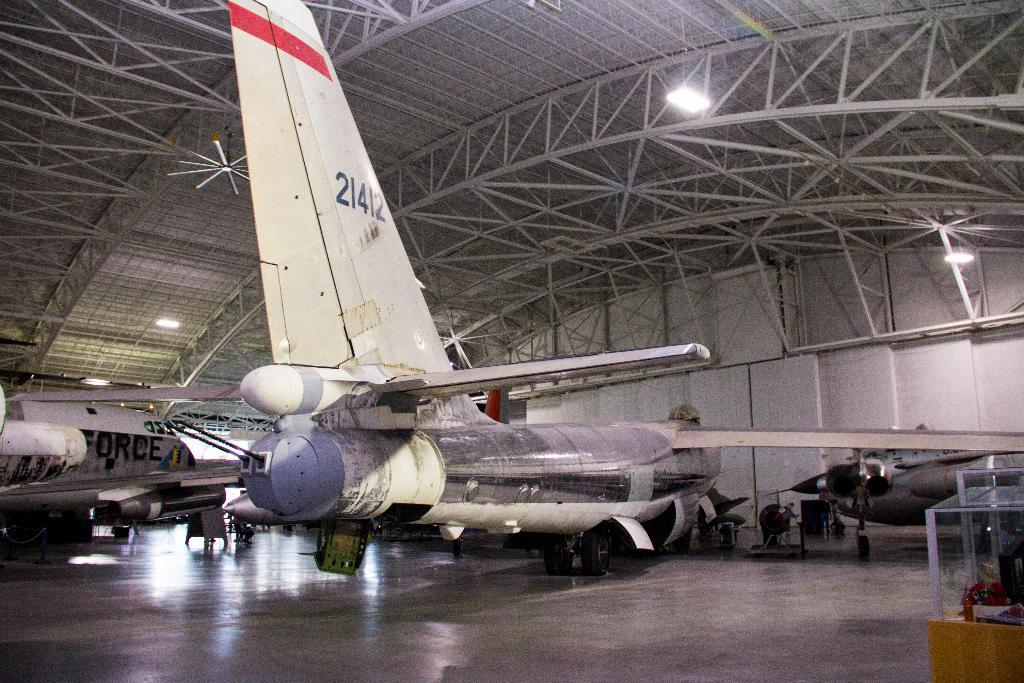What type of vehicles are inside the shed in the image? There are airplanes in a shed in the image. What can be seen in the image besides the airplanes? There are lights and iron rods visible in the image. What are the objects in glass boxes in the image? The objects in glass boxes are not specified in the provided facts. What type of pear is being used as a decoration in the cemetery in the image? There is no pear or cemetery present in the image; it features airplanes in a shed with lights and iron rods. 